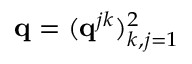<formula> <loc_0><loc_0><loc_500><loc_500>q = ( q ^ { j k } ) _ { k , j = 1 } ^ { 2 }</formula> 